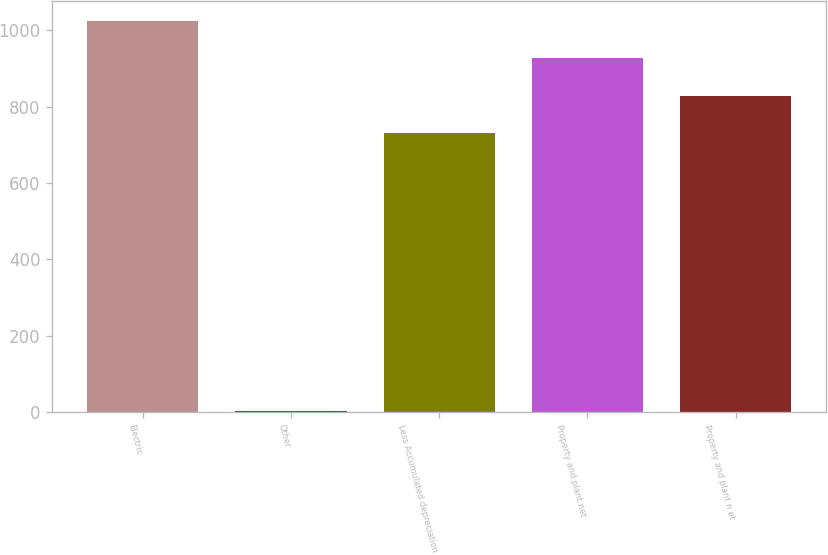Convert chart. <chart><loc_0><loc_0><loc_500><loc_500><bar_chart><fcel>Electric<fcel>Other<fcel>Less Accumulated depreciation<fcel>Property and plant net<fcel>Property and plant n et<nl><fcel>1025.2<fcel>3<fcel>730<fcel>926.8<fcel>828.4<nl></chart> 